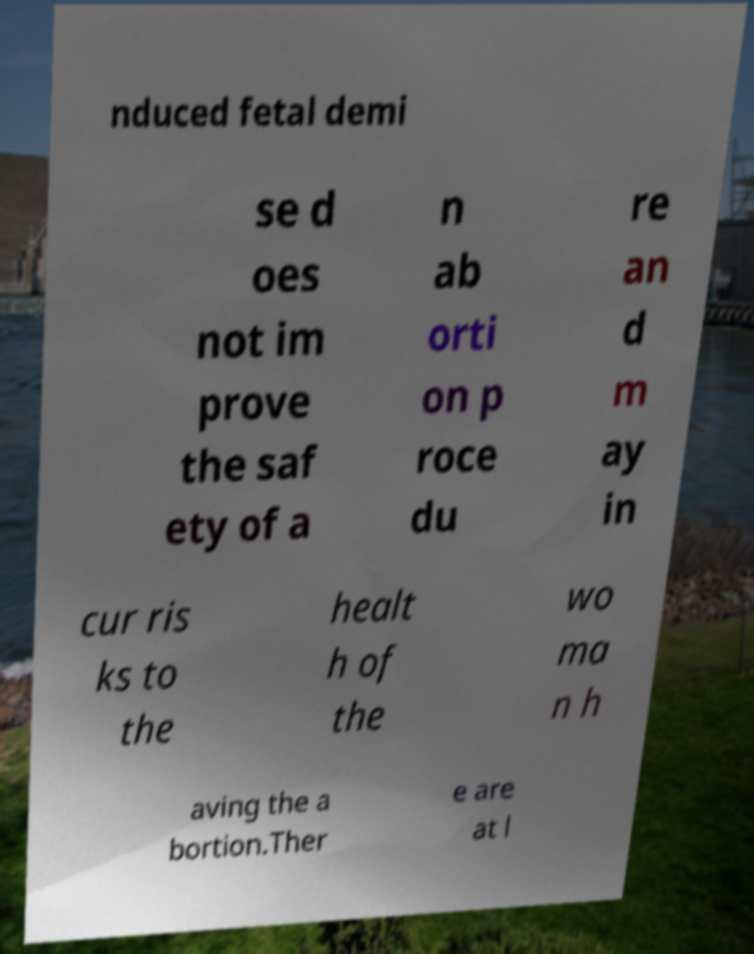Please identify and transcribe the text found in this image. nduced fetal demi se d oes not im prove the saf ety of a n ab orti on p roce du re an d m ay in cur ris ks to the healt h of the wo ma n h aving the a bortion.Ther e are at l 